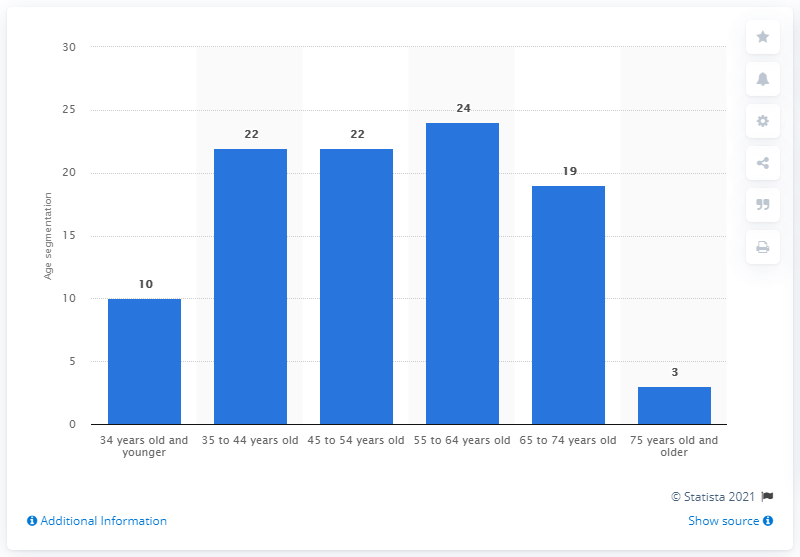Highlight a few significant elements in this photo. In 2010, 22% of customers were between the ages of 45 and 54. 